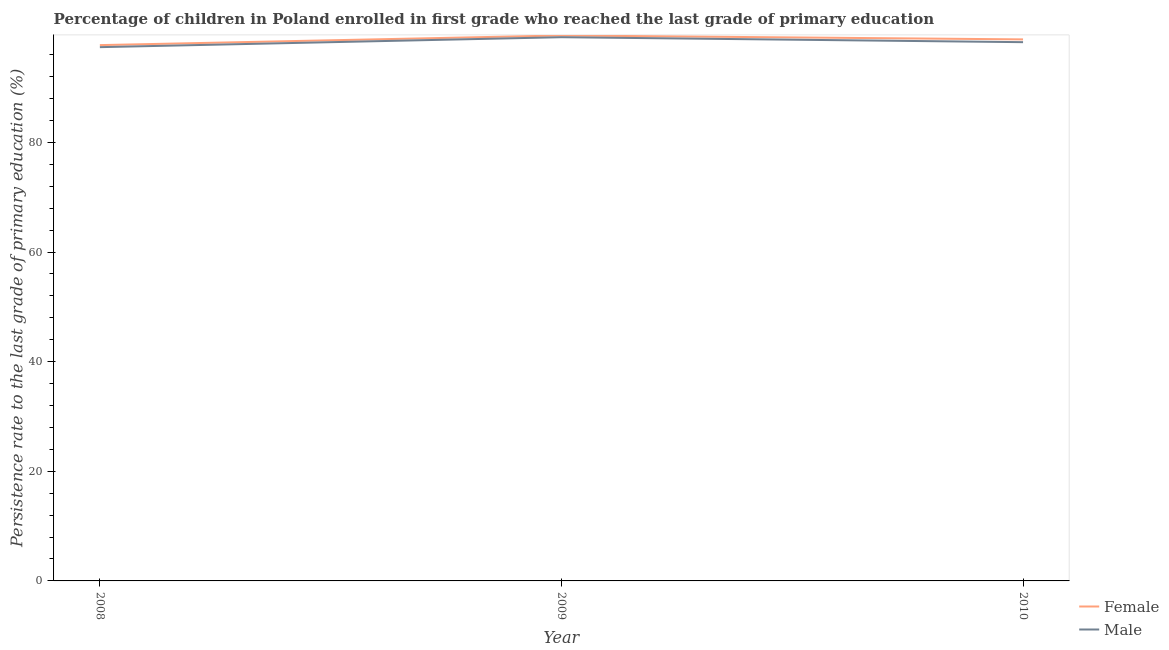How many different coloured lines are there?
Offer a very short reply. 2. Does the line corresponding to persistence rate of male students intersect with the line corresponding to persistence rate of female students?
Ensure brevity in your answer.  No. Is the number of lines equal to the number of legend labels?
Keep it short and to the point. Yes. What is the persistence rate of female students in 2010?
Give a very brief answer. 98.79. Across all years, what is the maximum persistence rate of male students?
Provide a short and direct response. 99.19. Across all years, what is the minimum persistence rate of female students?
Give a very brief answer. 97.75. In which year was the persistence rate of female students maximum?
Offer a terse response. 2009. What is the total persistence rate of male students in the graph?
Ensure brevity in your answer.  294.85. What is the difference between the persistence rate of male students in 2008 and that in 2010?
Provide a short and direct response. -0.91. What is the difference between the persistence rate of female students in 2008 and the persistence rate of male students in 2010?
Make the answer very short. -0.54. What is the average persistence rate of male students per year?
Provide a short and direct response. 98.28. In the year 2010, what is the difference between the persistence rate of male students and persistence rate of female students?
Make the answer very short. -0.51. What is the ratio of the persistence rate of male students in 2008 to that in 2009?
Provide a succinct answer. 0.98. Is the difference between the persistence rate of female students in 2008 and 2009 greater than the difference between the persistence rate of male students in 2008 and 2009?
Your answer should be compact. Yes. What is the difference between the highest and the second highest persistence rate of male students?
Your response must be concise. 0.9. What is the difference between the highest and the lowest persistence rate of male students?
Make the answer very short. 1.81. Does the persistence rate of male students monotonically increase over the years?
Your answer should be compact. No. How many years are there in the graph?
Offer a terse response. 3. Does the graph contain grids?
Provide a short and direct response. No. Where does the legend appear in the graph?
Provide a short and direct response. Bottom right. How many legend labels are there?
Offer a terse response. 2. How are the legend labels stacked?
Keep it short and to the point. Vertical. What is the title of the graph?
Make the answer very short. Percentage of children in Poland enrolled in first grade who reached the last grade of primary education. Does "Exports" appear as one of the legend labels in the graph?
Your answer should be very brief. No. What is the label or title of the X-axis?
Offer a very short reply. Year. What is the label or title of the Y-axis?
Make the answer very short. Persistence rate to the last grade of primary education (%). What is the Persistence rate to the last grade of primary education (%) in Female in 2008?
Your answer should be very brief. 97.75. What is the Persistence rate to the last grade of primary education (%) of Male in 2008?
Provide a succinct answer. 97.38. What is the Persistence rate to the last grade of primary education (%) in Female in 2009?
Ensure brevity in your answer.  99.51. What is the Persistence rate to the last grade of primary education (%) of Male in 2009?
Make the answer very short. 99.19. What is the Persistence rate to the last grade of primary education (%) of Female in 2010?
Offer a very short reply. 98.79. What is the Persistence rate to the last grade of primary education (%) of Male in 2010?
Offer a terse response. 98.29. Across all years, what is the maximum Persistence rate to the last grade of primary education (%) of Female?
Make the answer very short. 99.51. Across all years, what is the maximum Persistence rate to the last grade of primary education (%) of Male?
Keep it short and to the point. 99.19. Across all years, what is the minimum Persistence rate to the last grade of primary education (%) of Female?
Make the answer very short. 97.75. Across all years, what is the minimum Persistence rate to the last grade of primary education (%) of Male?
Give a very brief answer. 97.38. What is the total Persistence rate to the last grade of primary education (%) of Female in the graph?
Your answer should be very brief. 296.05. What is the total Persistence rate to the last grade of primary education (%) of Male in the graph?
Provide a succinct answer. 294.85. What is the difference between the Persistence rate to the last grade of primary education (%) in Female in 2008 and that in 2009?
Provide a succinct answer. -1.76. What is the difference between the Persistence rate to the last grade of primary education (%) in Male in 2008 and that in 2009?
Keep it short and to the point. -1.81. What is the difference between the Persistence rate to the last grade of primary education (%) in Female in 2008 and that in 2010?
Provide a succinct answer. -1.04. What is the difference between the Persistence rate to the last grade of primary education (%) in Male in 2008 and that in 2010?
Offer a terse response. -0.91. What is the difference between the Persistence rate to the last grade of primary education (%) of Female in 2009 and that in 2010?
Ensure brevity in your answer.  0.72. What is the difference between the Persistence rate to the last grade of primary education (%) of Male in 2009 and that in 2010?
Your response must be concise. 0.9. What is the difference between the Persistence rate to the last grade of primary education (%) of Female in 2008 and the Persistence rate to the last grade of primary education (%) of Male in 2009?
Offer a terse response. -1.44. What is the difference between the Persistence rate to the last grade of primary education (%) in Female in 2008 and the Persistence rate to the last grade of primary education (%) in Male in 2010?
Give a very brief answer. -0.54. What is the difference between the Persistence rate to the last grade of primary education (%) of Female in 2009 and the Persistence rate to the last grade of primary education (%) of Male in 2010?
Your answer should be compact. 1.22. What is the average Persistence rate to the last grade of primary education (%) in Female per year?
Provide a short and direct response. 98.68. What is the average Persistence rate to the last grade of primary education (%) of Male per year?
Keep it short and to the point. 98.28. In the year 2008, what is the difference between the Persistence rate to the last grade of primary education (%) of Female and Persistence rate to the last grade of primary education (%) of Male?
Offer a terse response. 0.37. In the year 2009, what is the difference between the Persistence rate to the last grade of primary education (%) in Female and Persistence rate to the last grade of primary education (%) in Male?
Make the answer very short. 0.32. In the year 2010, what is the difference between the Persistence rate to the last grade of primary education (%) in Female and Persistence rate to the last grade of primary education (%) in Male?
Keep it short and to the point. 0.51. What is the ratio of the Persistence rate to the last grade of primary education (%) in Female in 2008 to that in 2009?
Provide a short and direct response. 0.98. What is the ratio of the Persistence rate to the last grade of primary education (%) of Male in 2008 to that in 2009?
Keep it short and to the point. 0.98. What is the ratio of the Persistence rate to the last grade of primary education (%) in Female in 2008 to that in 2010?
Your answer should be compact. 0.99. What is the ratio of the Persistence rate to the last grade of primary education (%) in Male in 2008 to that in 2010?
Your answer should be compact. 0.99. What is the ratio of the Persistence rate to the last grade of primary education (%) of Female in 2009 to that in 2010?
Your answer should be very brief. 1.01. What is the ratio of the Persistence rate to the last grade of primary education (%) of Male in 2009 to that in 2010?
Provide a succinct answer. 1.01. What is the difference between the highest and the second highest Persistence rate to the last grade of primary education (%) in Female?
Provide a short and direct response. 0.72. What is the difference between the highest and the second highest Persistence rate to the last grade of primary education (%) in Male?
Ensure brevity in your answer.  0.9. What is the difference between the highest and the lowest Persistence rate to the last grade of primary education (%) in Female?
Ensure brevity in your answer.  1.76. What is the difference between the highest and the lowest Persistence rate to the last grade of primary education (%) of Male?
Ensure brevity in your answer.  1.81. 